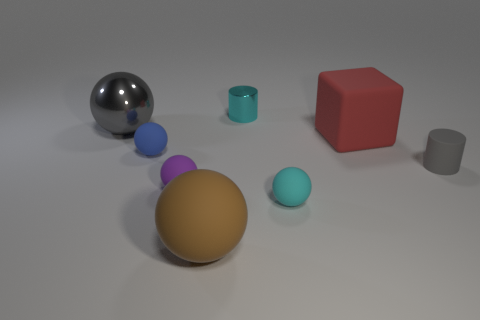There is a object that is left of the blue matte ball; does it have the same color as the large matte ball?
Make the answer very short. No. Is the color of the rubber ball that is to the right of the cyan metallic thing the same as the thing behind the large gray metal ball?
Provide a short and direct response. Yes. Is there a cylinder made of the same material as the small gray object?
Make the answer very short. No. How many gray objects are big things or cylinders?
Your answer should be compact. 2. Are there more gray cylinders that are behind the purple matte thing than tiny red rubber cylinders?
Give a very brief answer. Yes. Is the gray rubber cylinder the same size as the cyan cylinder?
Provide a succinct answer. Yes. What color is the large cube that is made of the same material as the small gray thing?
Ensure brevity in your answer.  Red. There is a object that is the same color as the small shiny cylinder; what shape is it?
Offer a terse response. Sphere. Is the number of red matte things in front of the small blue sphere the same as the number of red rubber objects that are behind the big gray metal object?
Make the answer very short. Yes. There is a large thing in front of the cylinder that is in front of the red thing; what shape is it?
Your answer should be compact. Sphere. 